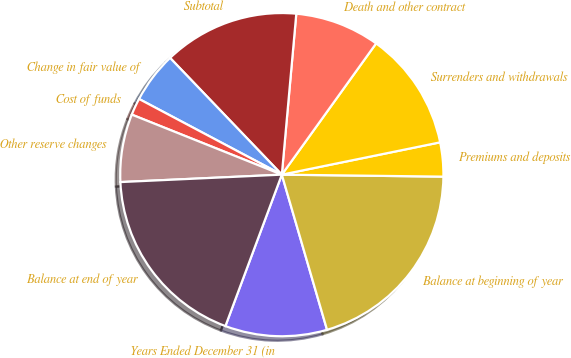Convert chart to OTSL. <chart><loc_0><loc_0><loc_500><loc_500><pie_chart><fcel>Years Ended December 31 (in<fcel>Balance at beginning of year<fcel>Premiums and deposits<fcel>Surrenders and withdrawals<fcel>Death and other contract<fcel>Subtotal<fcel>Change in fair value of<fcel>Cost of funds<fcel>Other reserve changes<fcel>Balance at end of year<nl><fcel>10.19%<fcel>20.29%<fcel>3.4%<fcel>11.88%<fcel>8.49%<fcel>13.58%<fcel>5.09%<fcel>1.7%<fcel>6.79%<fcel>18.59%<nl></chart> 